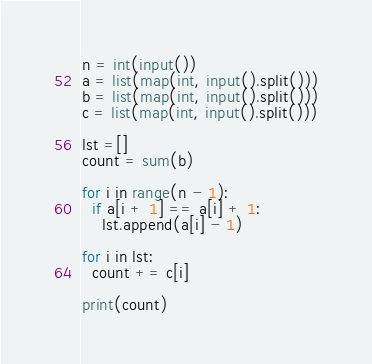Convert code to text. <code><loc_0><loc_0><loc_500><loc_500><_Python_>n = int(input())
a = list(map(int, input().split()))
b = list(map(int, input().split()))
c = list(map(int, input().split()))

lst =[]
count = sum(b)

for i in range(n - 1):
  if a[i + 1] == a[i] + 1:
    lst.append(a[i] - 1)
  
for i in lst:
  count += c[i]
  
print(count)</code> 